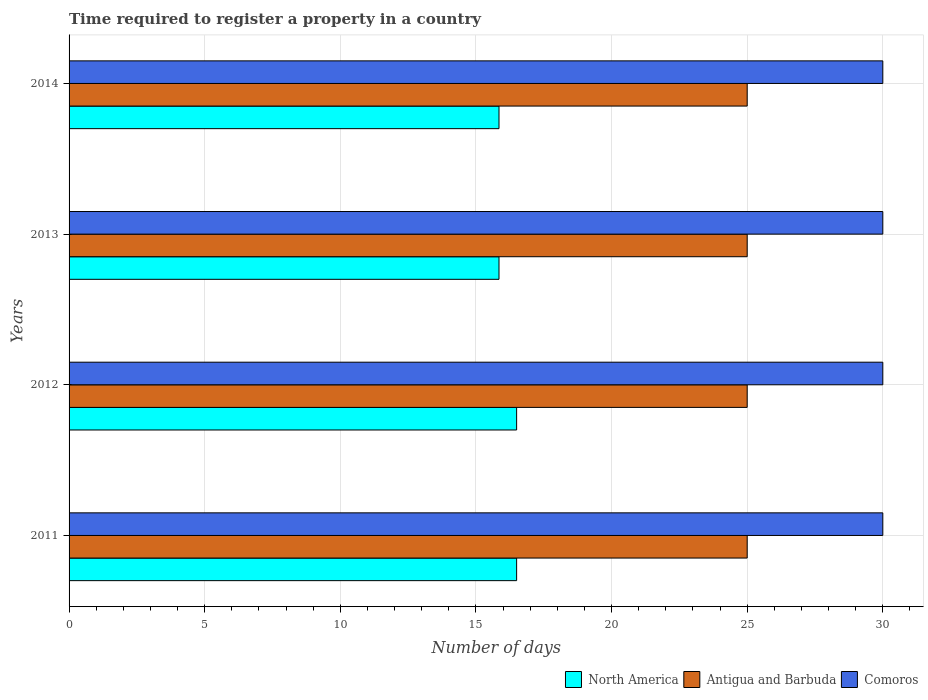How many different coloured bars are there?
Your answer should be very brief. 3. How many groups of bars are there?
Your answer should be very brief. 4. Are the number of bars per tick equal to the number of legend labels?
Offer a terse response. Yes. How many bars are there on the 1st tick from the top?
Give a very brief answer. 3. How many bars are there on the 4th tick from the bottom?
Offer a very short reply. 3. What is the label of the 1st group of bars from the top?
Your answer should be compact. 2014. In how many cases, is the number of bars for a given year not equal to the number of legend labels?
Offer a very short reply. 0. Across all years, what is the maximum number of days required to register a property in Antigua and Barbuda?
Ensure brevity in your answer.  25. Across all years, what is the minimum number of days required to register a property in North America?
Keep it short and to the point. 15.85. In which year was the number of days required to register a property in North America maximum?
Offer a terse response. 2011. In which year was the number of days required to register a property in Antigua and Barbuda minimum?
Your answer should be very brief. 2011. What is the total number of days required to register a property in North America in the graph?
Provide a short and direct response. 64.7. What is the difference between the number of days required to register a property in Antigua and Barbuda in 2014 and the number of days required to register a property in Comoros in 2013?
Your answer should be very brief. -5. In the year 2013, what is the difference between the number of days required to register a property in North America and number of days required to register a property in Comoros?
Your answer should be very brief. -14.15. In how many years, is the number of days required to register a property in North America greater than 9 days?
Give a very brief answer. 4. What is the difference between the highest and the second highest number of days required to register a property in North America?
Offer a terse response. 0. What is the difference between the highest and the lowest number of days required to register a property in North America?
Your answer should be very brief. 0.65. In how many years, is the number of days required to register a property in Antigua and Barbuda greater than the average number of days required to register a property in Antigua and Barbuda taken over all years?
Provide a succinct answer. 0. What does the 2nd bar from the top in 2013 represents?
Make the answer very short. Antigua and Barbuda. What does the 2nd bar from the bottom in 2011 represents?
Your response must be concise. Antigua and Barbuda. How many bars are there?
Make the answer very short. 12. Does the graph contain any zero values?
Ensure brevity in your answer.  No. How many legend labels are there?
Provide a short and direct response. 3. What is the title of the graph?
Offer a terse response. Time required to register a property in a country. What is the label or title of the X-axis?
Keep it short and to the point. Number of days. What is the label or title of the Y-axis?
Keep it short and to the point. Years. What is the Number of days in North America in 2011?
Offer a terse response. 16.5. What is the Number of days in North America in 2012?
Keep it short and to the point. 16.5. What is the Number of days in Antigua and Barbuda in 2012?
Offer a terse response. 25. What is the Number of days of North America in 2013?
Ensure brevity in your answer.  15.85. What is the Number of days in Comoros in 2013?
Offer a terse response. 30. What is the Number of days in North America in 2014?
Your response must be concise. 15.85. What is the Number of days in Comoros in 2014?
Your response must be concise. 30. Across all years, what is the minimum Number of days in North America?
Provide a succinct answer. 15.85. Across all years, what is the minimum Number of days in Antigua and Barbuda?
Offer a terse response. 25. Across all years, what is the minimum Number of days of Comoros?
Your response must be concise. 30. What is the total Number of days of North America in the graph?
Make the answer very short. 64.7. What is the total Number of days in Comoros in the graph?
Keep it short and to the point. 120. What is the difference between the Number of days of North America in 2011 and that in 2012?
Your response must be concise. 0. What is the difference between the Number of days of North America in 2011 and that in 2013?
Ensure brevity in your answer.  0.65. What is the difference between the Number of days of Comoros in 2011 and that in 2013?
Your answer should be compact. 0. What is the difference between the Number of days in North America in 2011 and that in 2014?
Your answer should be compact. 0.65. What is the difference between the Number of days in Antigua and Barbuda in 2011 and that in 2014?
Your answer should be compact. 0. What is the difference between the Number of days of Comoros in 2011 and that in 2014?
Make the answer very short. 0. What is the difference between the Number of days in North America in 2012 and that in 2013?
Offer a very short reply. 0.65. What is the difference between the Number of days in Comoros in 2012 and that in 2013?
Provide a succinct answer. 0. What is the difference between the Number of days in North America in 2012 and that in 2014?
Keep it short and to the point. 0.65. What is the difference between the Number of days in Antigua and Barbuda in 2012 and that in 2014?
Offer a very short reply. 0. What is the difference between the Number of days in North America in 2013 and that in 2014?
Your answer should be compact. 0. What is the difference between the Number of days of Comoros in 2013 and that in 2014?
Offer a very short reply. 0. What is the difference between the Number of days of North America in 2011 and the Number of days of Comoros in 2012?
Give a very brief answer. -13.5. What is the difference between the Number of days in Antigua and Barbuda in 2011 and the Number of days in Comoros in 2013?
Ensure brevity in your answer.  -5. What is the difference between the Number of days of North America in 2012 and the Number of days of Antigua and Barbuda in 2013?
Provide a succinct answer. -8.5. What is the difference between the Number of days of North America in 2012 and the Number of days of Comoros in 2013?
Keep it short and to the point. -13.5. What is the difference between the Number of days of North America in 2012 and the Number of days of Comoros in 2014?
Your answer should be very brief. -13.5. What is the difference between the Number of days in Antigua and Barbuda in 2012 and the Number of days in Comoros in 2014?
Provide a short and direct response. -5. What is the difference between the Number of days in North America in 2013 and the Number of days in Antigua and Barbuda in 2014?
Make the answer very short. -9.15. What is the difference between the Number of days of North America in 2013 and the Number of days of Comoros in 2014?
Your response must be concise. -14.15. What is the difference between the Number of days of Antigua and Barbuda in 2013 and the Number of days of Comoros in 2014?
Provide a short and direct response. -5. What is the average Number of days of North America per year?
Provide a succinct answer. 16.18. What is the average Number of days in Antigua and Barbuda per year?
Offer a very short reply. 25. What is the average Number of days of Comoros per year?
Offer a terse response. 30. In the year 2011, what is the difference between the Number of days in North America and Number of days in Comoros?
Offer a terse response. -13.5. In the year 2012, what is the difference between the Number of days in North America and Number of days in Antigua and Barbuda?
Your response must be concise. -8.5. In the year 2012, what is the difference between the Number of days in Antigua and Barbuda and Number of days in Comoros?
Provide a short and direct response. -5. In the year 2013, what is the difference between the Number of days of North America and Number of days of Antigua and Barbuda?
Ensure brevity in your answer.  -9.15. In the year 2013, what is the difference between the Number of days of North America and Number of days of Comoros?
Provide a succinct answer. -14.15. In the year 2013, what is the difference between the Number of days of Antigua and Barbuda and Number of days of Comoros?
Make the answer very short. -5. In the year 2014, what is the difference between the Number of days of North America and Number of days of Antigua and Barbuda?
Offer a terse response. -9.15. In the year 2014, what is the difference between the Number of days in North America and Number of days in Comoros?
Keep it short and to the point. -14.15. What is the ratio of the Number of days in Antigua and Barbuda in 2011 to that in 2012?
Provide a short and direct response. 1. What is the ratio of the Number of days in North America in 2011 to that in 2013?
Your response must be concise. 1.04. What is the ratio of the Number of days of Antigua and Barbuda in 2011 to that in 2013?
Provide a succinct answer. 1. What is the ratio of the Number of days in North America in 2011 to that in 2014?
Your answer should be very brief. 1.04. What is the ratio of the Number of days of Antigua and Barbuda in 2011 to that in 2014?
Your answer should be very brief. 1. What is the ratio of the Number of days of North America in 2012 to that in 2013?
Keep it short and to the point. 1.04. What is the ratio of the Number of days in Antigua and Barbuda in 2012 to that in 2013?
Ensure brevity in your answer.  1. What is the ratio of the Number of days in North America in 2012 to that in 2014?
Keep it short and to the point. 1.04. What is the ratio of the Number of days of Comoros in 2012 to that in 2014?
Ensure brevity in your answer.  1. What is the ratio of the Number of days in North America in 2013 to that in 2014?
Your answer should be compact. 1. What is the ratio of the Number of days in Antigua and Barbuda in 2013 to that in 2014?
Offer a terse response. 1. What is the difference between the highest and the second highest Number of days of North America?
Make the answer very short. 0. What is the difference between the highest and the second highest Number of days in Antigua and Barbuda?
Your response must be concise. 0. What is the difference between the highest and the lowest Number of days in North America?
Offer a very short reply. 0.65. 